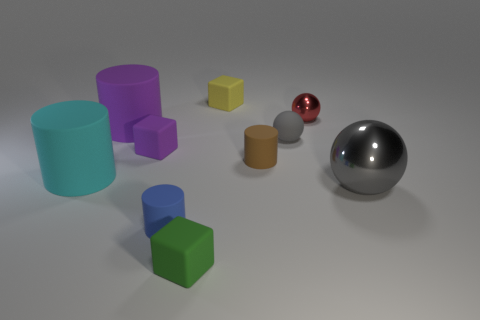Is the shape of the rubber object that is behind the tiny red shiny object the same as  the small gray thing?
Your response must be concise. No. Is the number of small purple things in front of the gray metallic sphere less than the number of purple cubes behind the large purple rubber cylinder?
Your answer should be compact. No. There is a thing to the left of the big purple rubber thing; what material is it?
Make the answer very short. Rubber. There is a matte thing that is the same color as the large ball; what size is it?
Your answer should be very brief. Small. Are there any brown matte cylinders of the same size as the matte ball?
Your answer should be compact. Yes. There is a gray metallic thing; does it have the same shape as the gray thing behind the small brown thing?
Your answer should be very brief. Yes. Is the size of the cylinder that is to the right of the yellow object the same as the gray sphere that is in front of the brown matte object?
Ensure brevity in your answer.  No. What number of other objects are there of the same shape as the large purple object?
Provide a short and direct response. 3. What material is the small block in front of the small cylinder that is to the left of the yellow thing?
Offer a very short reply. Rubber. How many metal objects are large purple things or tiny green cubes?
Offer a terse response. 0. 